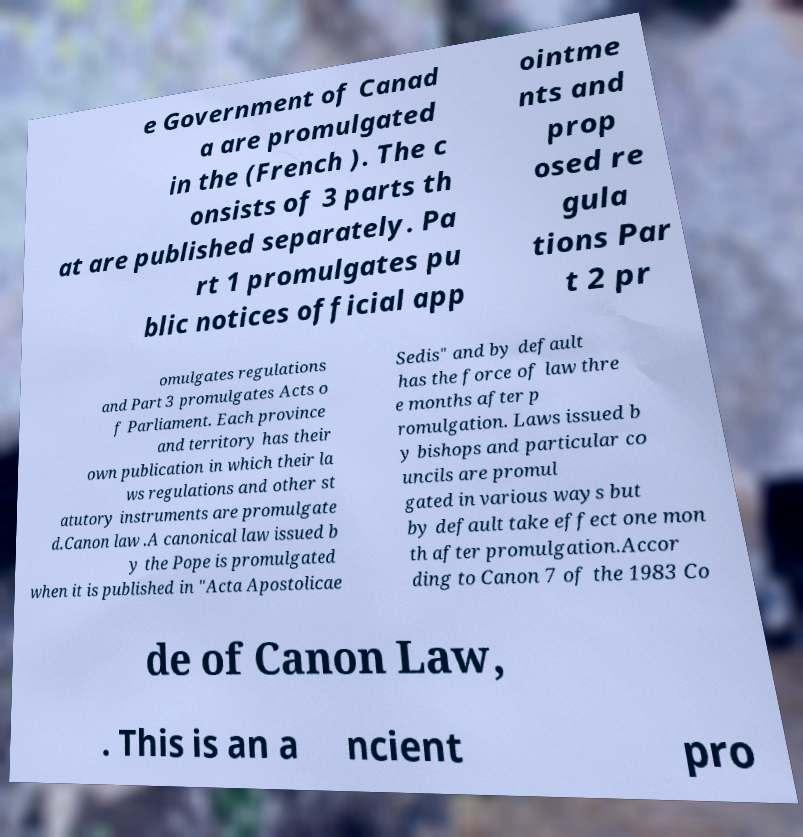Can you accurately transcribe the text from the provided image for me? e Government of Canad a are promulgated in the (French ). The c onsists of 3 parts th at are published separately. Pa rt 1 promulgates pu blic notices official app ointme nts and prop osed re gula tions Par t 2 pr omulgates regulations and Part 3 promulgates Acts o f Parliament. Each province and territory has their own publication in which their la ws regulations and other st atutory instruments are promulgate d.Canon law .A canonical law issued b y the Pope is promulgated when it is published in "Acta Apostolicae Sedis" and by default has the force of law thre e months after p romulgation. Laws issued b y bishops and particular co uncils are promul gated in various ways but by default take effect one mon th after promulgation.Accor ding to Canon 7 of the 1983 Co de of Canon Law, . This is an a ncient pro 